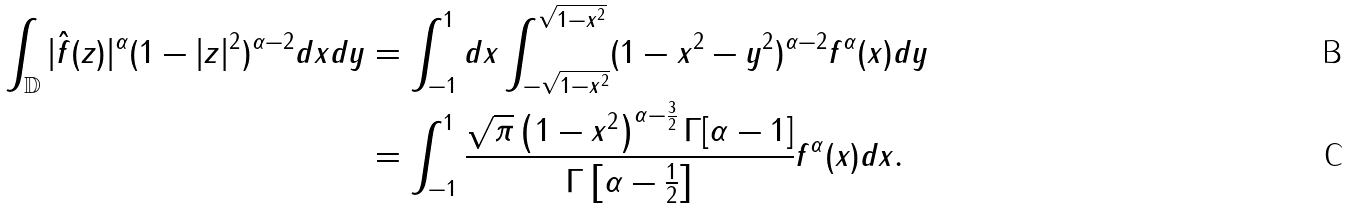Convert formula to latex. <formula><loc_0><loc_0><loc_500><loc_500>\int _ { \mathbb { D } } | \hat { f } ( z ) | ^ { \alpha } ( 1 - | z | ^ { 2 } ) ^ { \alpha - 2 } { d x d y } & = \int _ { - 1 } ^ { 1 } d x \int _ { - \sqrt { 1 - x ^ { 2 } } } ^ { \sqrt { 1 - x ^ { 2 } } } ( 1 - x ^ { 2 } - y ^ { 2 } ) ^ { \alpha - 2 } f ^ { \alpha } ( x ) d y \\ & = \int _ { - 1 } ^ { 1 } \frac { \sqrt { \pi } \left ( 1 - x ^ { 2 } \right ) ^ { \alpha - \frac { 3 } { 2 } } \Gamma [ \alpha - 1 ] } { \Gamma \left [ \alpha - \frac { 1 } { 2 } \right ] } f ^ { \alpha } ( x ) d x .</formula> 